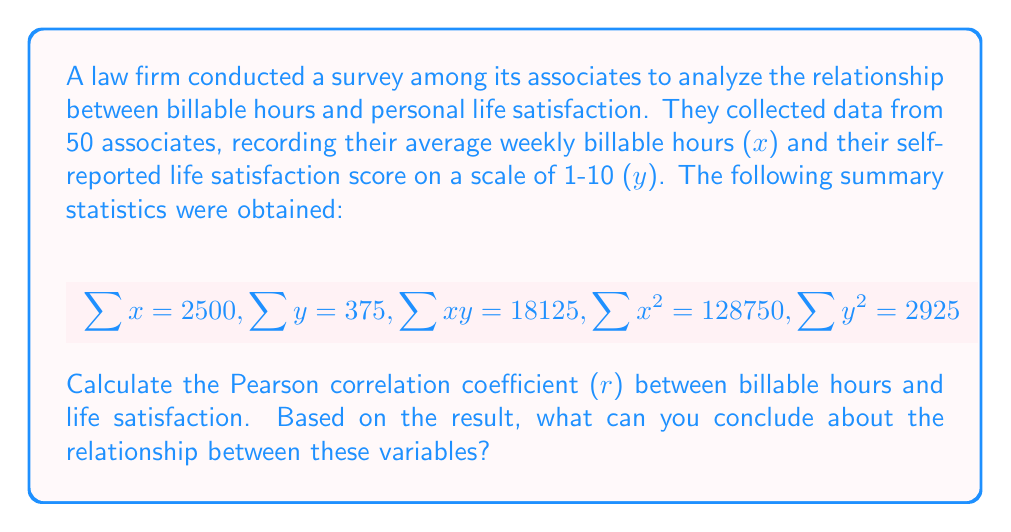Can you answer this question? To calculate the Pearson correlation coefficient (r), we'll use the formula:

$$r = \frac{n\sum xy - \sum x \sum y}{\sqrt{[n\sum x^2 - (\sum x)^2][n\sum y^2 - (\sum y)^2]}}$$

Where n is the number of data points (50 in this case).

Step 1: Calculate $n\sum xy$
$n\sum xy = 50 \times 18125 = 906250$

Step 2: Calculate $\sum x \sum y$
$\sum x \sum y = 2500 \times 375 = 937500$

Step 3: Calculate $n\sum x^2$
$n\sum x^2 = 50 \times 128750 = 6437500$

Step 4: Calculate $(\sum x)^2$
$(\sum x)^2 = 2500^2 = 6250000$

Step 5: Calculate $n\sum y^2$
$n\sum y^2 = 50 \times 2925 = 146250$

Step 6: Calculate $(\sum y)^2$
$(\sum y)^2 = 375^2 = 140625$

Step 7: Substitute these values into the formula
$$r = \frac{906250 - 937500}{\sqrt{[6437500 - 6250000][146250 - 140625]}}$$

Step 8: Simplify
$$r = \frac{-31250}{\sqrt{187500 \times 5625}} = \frac{-31250}{\sqrt{1054687500}} = \frac{-31250}{32475.9}$$

Step 9: Calculate the final result
$$r \approx -0.9623$$

The Pearson correlation coefficient ranges from -1 to 1. A value of -0.9623 indicates a very strong negative correlation between billable hours and life satisfaction. This means that as billable hours increase, life satisfaction tends to decrease significantly.
Answer: $r \approx -0.9623$, indicating a very strong negative correlation between billable hours and life satisfaction. 